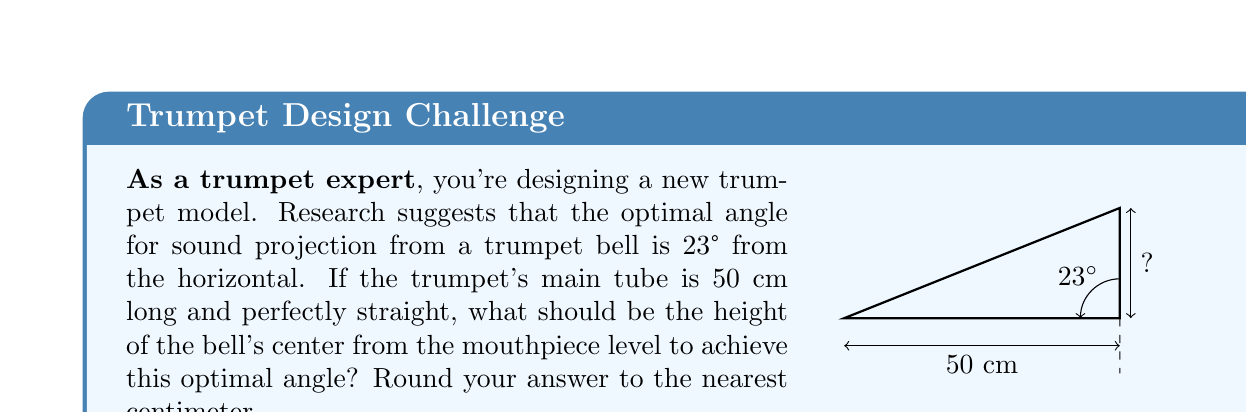Solve this math problem. Let's approach this step-by-step:

1) We can treat this as a right-angled triangle problem. The trumpet's main tube forms the base of the triangle, and we need to find the height.

2) We know:
   - The angle of elevation (optimal angle) = 23°
   - The length of the base (trumpet tube) = 50 cm

3) In a right-angled triangle, tangent of an angle is the ratio of the opposite side to the adjacent side:

   $$\tan(\theta) = \frac{\text{opposite}}{\text{adjacent}}$$

4) In our case:
   $$\tan(23°) = \frac{\text{height}}{50\text{ cm}}$$

5) To find the height, we rearrange the equation:
   $$\text{height} = 50 \cdot \tan(23°)$$

6) Using a calculator (or a trigonometric table):
   $$\text{height} = 50 \cdot 0.4245 = 21.225\text{ cm}$$

7) Rounding to the nearest centimeter:
   $$\text{height} \approx 21\text{ cm}$$

Thus, the center of the bell should be 21 cm higher than the mouthpiece level to achieve the optimal 23° angle for sound projection.
Answer: 21 cm 